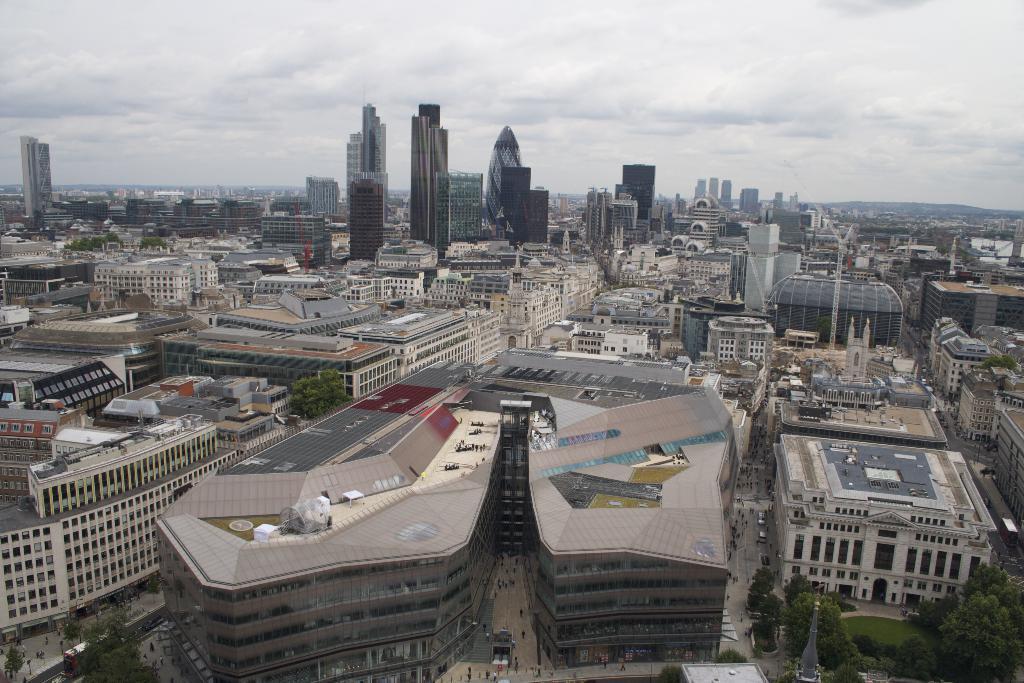Describe this image in one or two sentences. This image consists of many building and skyscrapers. And there are helipads on the building. To the top, there are clouds in the sky. At the bottom, there are roads along with trees and plants. 